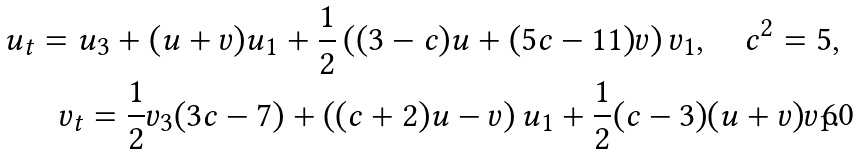Convert formula to latex. <formula><loc_0><loc_0><loc_500><loc_500>u _ { t } = u _ { 3 } + ( u + v ) u _ { 1 } + \frac { 1 } { 2 } \left ( ( 3 - c ) u + ( 5 c - 1 1 ) v \right ) v _ { 1 } , \quad c ^ { 2 } = 5 , \\ v _ { t } = \frac { 1 } { 2 } v _ { 3 } ( 3 c - 7 ) + \left ( ( c + 2 ) u - v \right ) u _ { 1 } + \frac { 1 } { 2 } ( c - 3 ) ( u + v ) v _ { 1 } .</formula> 